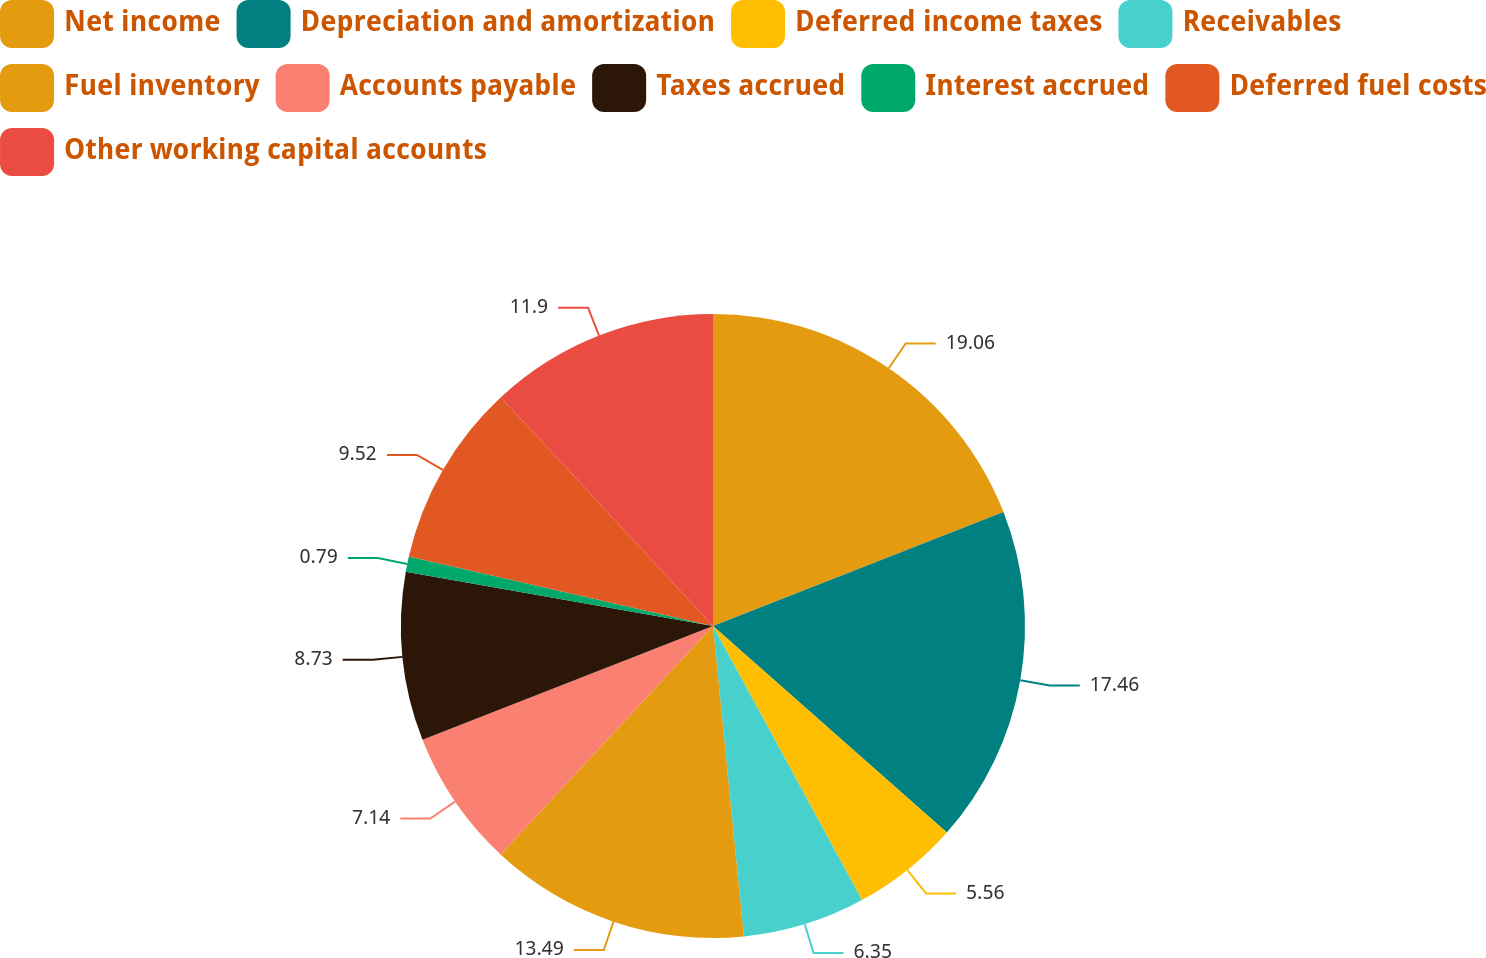Convert chart to OTSL. <chart><loc_0><loc_0><loc_500><loc_500><pie_chart><fcel>Net income<fcel>Depreciation and amortization<fcel>Deferred income taxes<fcel>Receivables<fcel>Fuel inventory<fcel>Accounts payable<fcel>Taxes accrued<fcel>Interest accrued<fcel>Deferred fuel costs<fcel>Other working capital accounts<nl><fcel>19.05%<fcel>17.46%<fcel>5.56%<fcel>6.35%<fcel>13.49%<fcel>7.14%<fcel>8.73%<fcel>0.79%<fcel>9.52%<fcel>11.9%<nl></chart> 